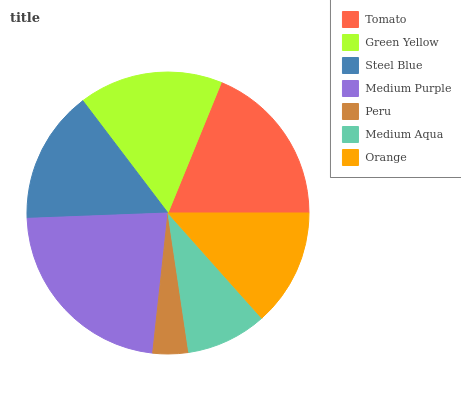Is Peru the minimum?
Answer yes or no. Yes. Is Medium Purple the maximum?
Answer yes or no. Yes. Is Green Yellow the minimum?
Answer yes or no. No. Is Green Yellow the maximum?
Answer yes or no. No. Is Tomato greater than Green Yellow?
Answer yes or no. Yes. Is Green Yellow less than Tomato?
Answer yes or no. Yes. Is Green Yellow greater than Tomato?
Answer yes or no. No. Is Tomato less than Green Yellow?
Answer yes or no. No. Is Steel Blue the high median?
Answer yes or no. Yes. Is Steel Blue the low median?
Answer yes or no. Yes. Is Orange the high median?
Answer yes or no. No. Is Orange the low median?
Answer yes or no. No. 